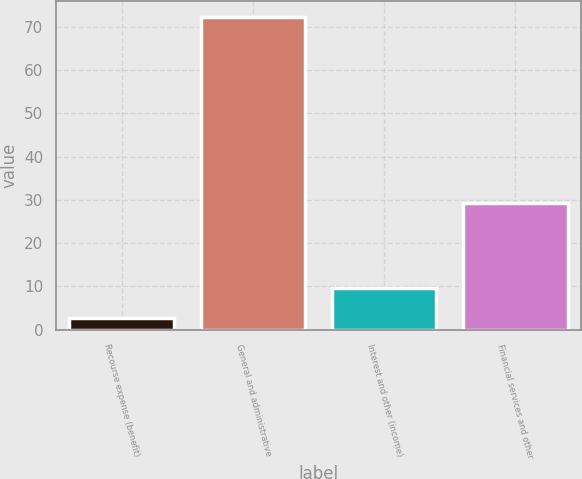<chart> <loc_0><loc_0><loc_500><loc_500><bar_chart><fcel>Recourse expense (benefit)<fcel>General and administrative<fcel>Interest and other (income)<fcel>Financial services and other<nl><fcel>2.8<fcel>72.3<fcel>9.75<fcel>29.3<nl></chart> 